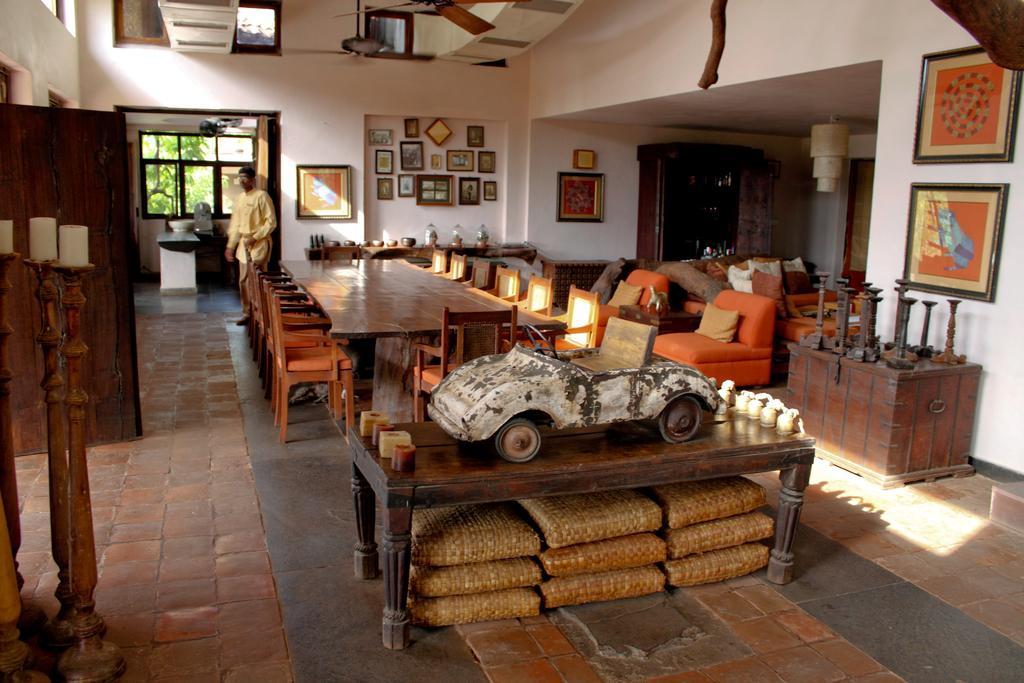How would you summarize this image in a sentence or two? He we see a table and Few chairs and a man standing and few photo frames on the wall and we see a toy car on the table. 